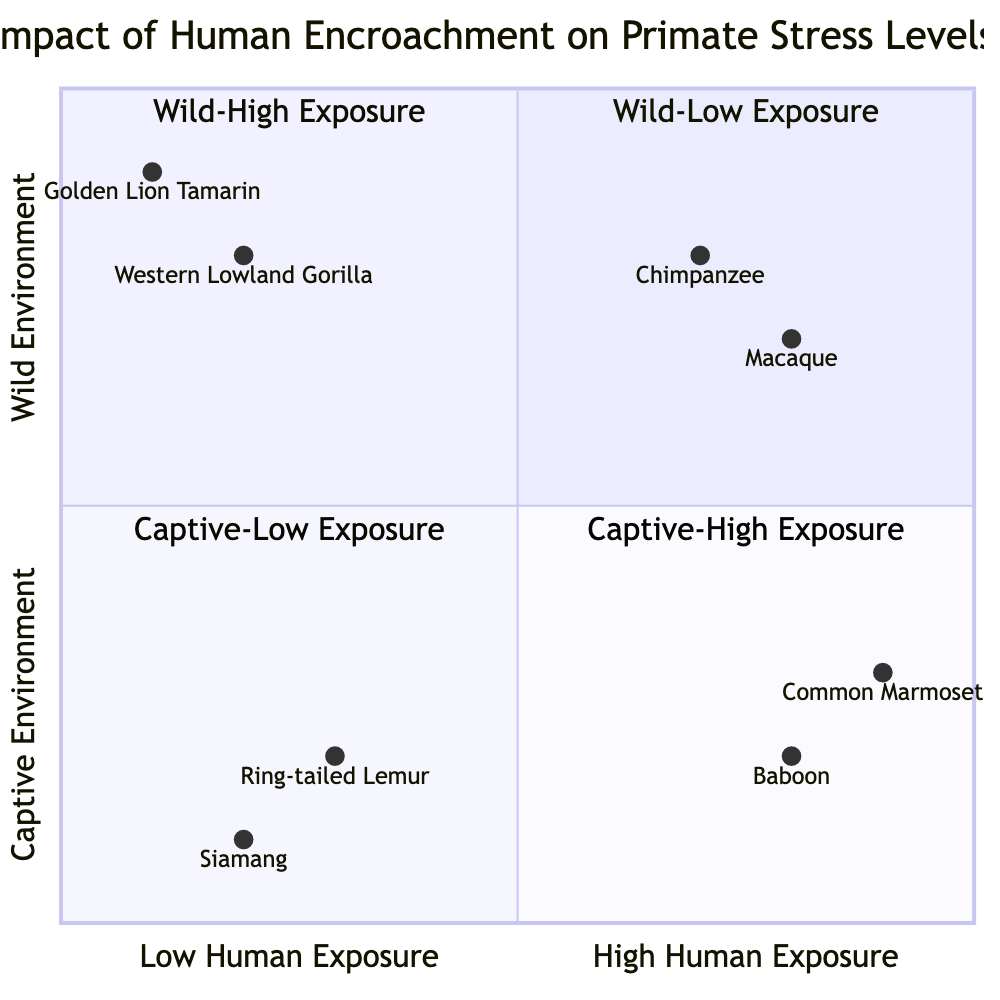What primate species is located in the "Wild-Low Exposure" quadrant? The "Wild-Low Exposure" quadrant includes the Western Lowland Gorilla and the Golden Lion Tamarin. The question specifically asks for a species name, and both species fit this description.
Answer: Western Lowland Gorilla Which quadrant contains primates with the highest human exposure? The quadrant with the highest human exposure is "Captive-High Exposure." This is determined by looking for the quadrant that represents captivity with frequent and varied human interaction.
Answer: Captive-High Exposure How many primate species are located in the "Captive-Low Exposure" quadrant? The "Captive-Low Exposure" quadrant includes the Ring-tailed Lemur and the Siamang. As there are two species listed here, the answer is derived from counting the species.
Answer: 2 What stress indicator is associated with the Common Marmoset? The Common Marmoset is associated with hyperactivity and self-mutilation behaviors, which are listed under stress indicators in the "Captive-High Exposure" quadrant. The question specifies a particular stress indicator.
Answer: Hyperactivity Which species exhibits disrupted social hierarchies due to human encroachment? The Chimpanzee in the "Wild-High Exposure" quadrant is identified with disrupted social hierarchies as a stress indicator, arising from conflicts with humans. This requires recognizing the stress indicators associated with the species.
Answer: Chimpanzee Among the primate species listed, which has the lowest cortisol levels? The Western Lowland Gorilla in the "Wild-Low Exposure" quadrant shows lower cortisol levels as one of its stress indicators, therefore directly answering the question by identifying the species with this characteristic.
Answer: Western Lowland Gorilla What is the common environmental context for the Baboon? The Baboon appears in the "Captive-High Exposure" quadrant, where it is subjected to high visitor interaction and feeding, indicating that its context is captivity with significant human presence. This context is tied to the quadrant's designation.
Answer: Captive-High Exposure Which species demonstrates regular health check-ups as a stress indicator? The Siamang in the "Captive-Low Exposure" quadrant exhibits regular health check-ups, according to the stress indicators for that species. This answer requires recalling specific indicators listed for the species.
Answer: Siamang 